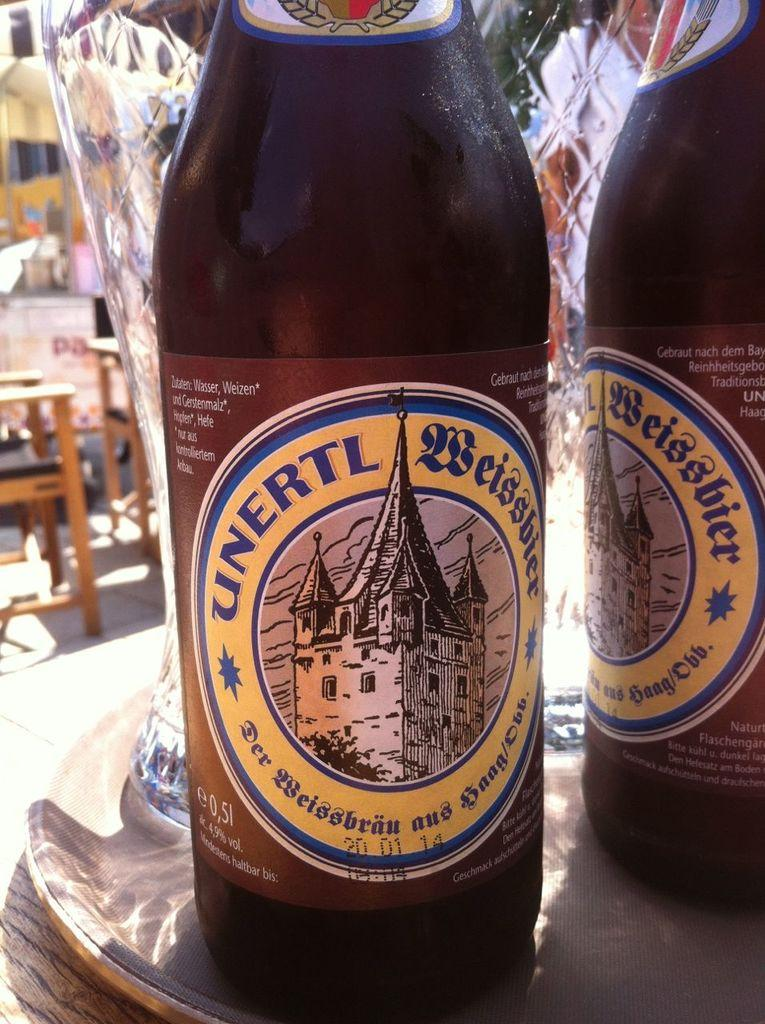Provide a one-sentence caption for the provided image. a close up of Unertl drink on a table outside. 